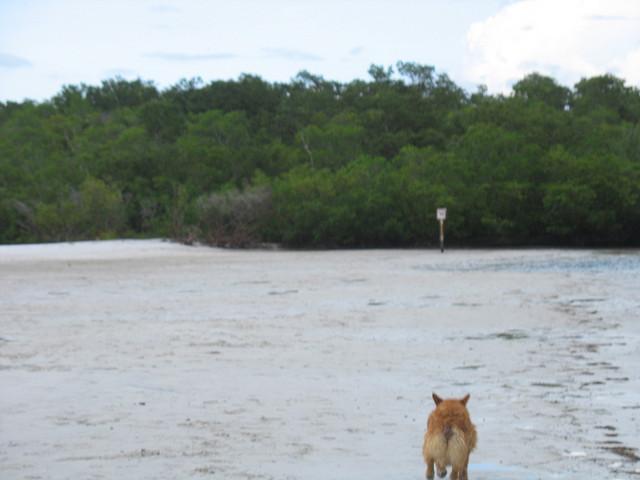How many dogs?
Give a very brief answer. 1. How many cars are to the left of the carriage?
Give a very brief answer. 0. 